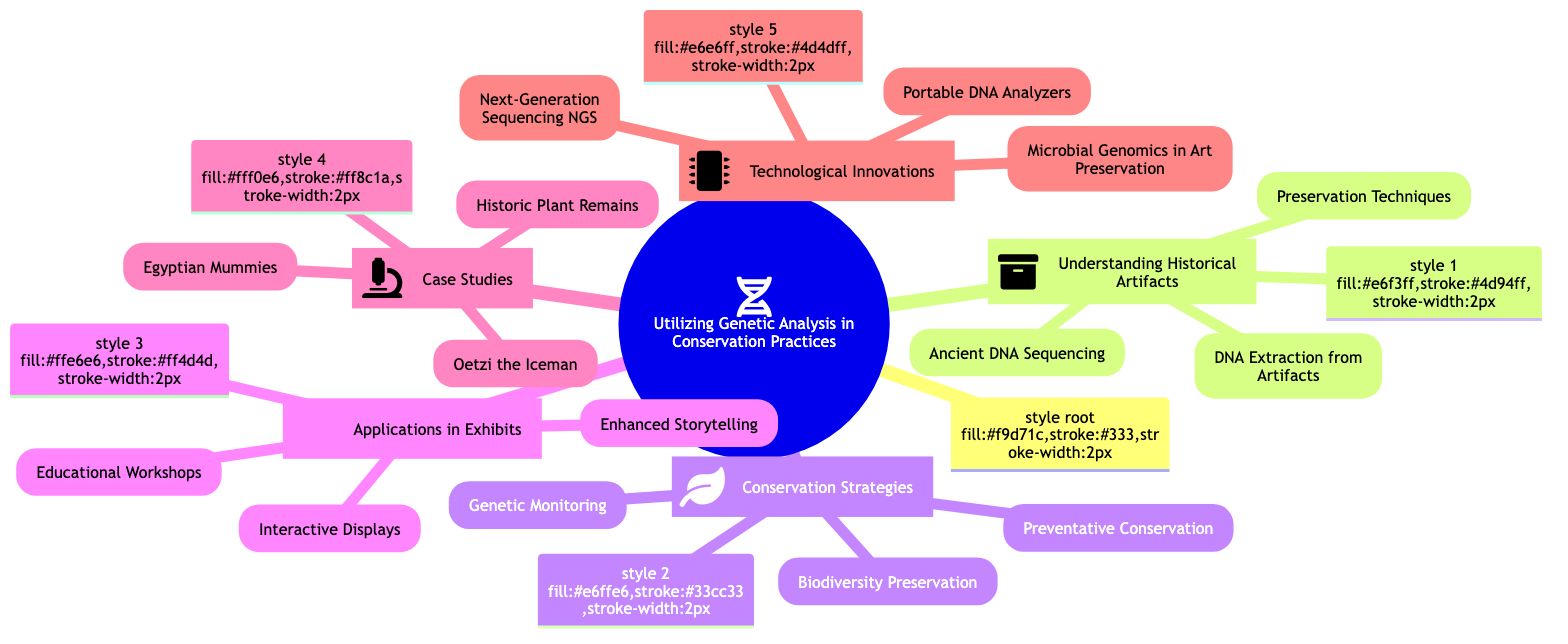What is the central topic of the mind map? The central topic is stated explicitly at the root of the diagram and is clearly labeled as "Utilizing Genetic Analysis in Conservation Practices."
Answer: Utilizing Genetic Analysis in Conservation Practices How many main branches are present in the diagram? The diagram contains five main branches that stem from the central topic, representing significant subtopics regarding the use of genetic analysis in conservation.
Answer: 5 What is a subtopic related to case studies in the diagram? The diagram lists "Case Studies" as a subtopic, and one of the elements under this subtopic is "Oetzi the Iceman." This answers the question directly by identifying the specific subtopic as requested.
Answer: Oetzi the Iceman Which technological innovation focuses on microbial genomics? Under the subtopic "Technological Innovations," the element that focuses on microbial genomics in art preservation is clearly labeled as "Microbial Genomics in Art Preservation."
Answer: Microbial Genomics in Art Preservation What are the three subbranches of "Applications in Exhibits"? The subbranches of "Applications in Exhibits" are explicitly listed as "Enhanced Storytelling," "Interactive Displays," and "Educational Workshops," detailing applications of genetic analysis in exhibits.
Answer: Enhanced Storytelling, Interactive Displays, Educational Workshops Which subtopic includes genetic monitoring? The element "Genetic Monitoring" is categorized under the subtopic "Conservation Strategies," indicating its relevance to conservation practices. By identifying the hierarchy, one recognizes where genetic monitoring fits within the broader theme.
Answer: Conservation Strategies How many elements are listed under "Understanding Historical Artifacts"? The diagram shows three elements under the subtopic "Understanding Historical Artifacts," which are "DNA Extraction from Artifacts," "Ancient DNA Sequencing," and "Preservation Techniques." This count verifies the subtopic's complexity.
Answer: 3 Which subtopic contains the element "Next-Generation Sequencing"? The element "Next-Generation Sequencing" is part of the subtopic "Technological Innovations," indicating advancements in technology used for genetic analysis in conservation.
Answer: Technological Innovations What do the icons in the branches represent? The icons placed next to each subtopic represent specific conceptual themes in the diagram, such as DNA for historical artifacts or a leaf for conservation strategies, visually aiding comprehension of the subject matter.
Answer: Conceptual themes 